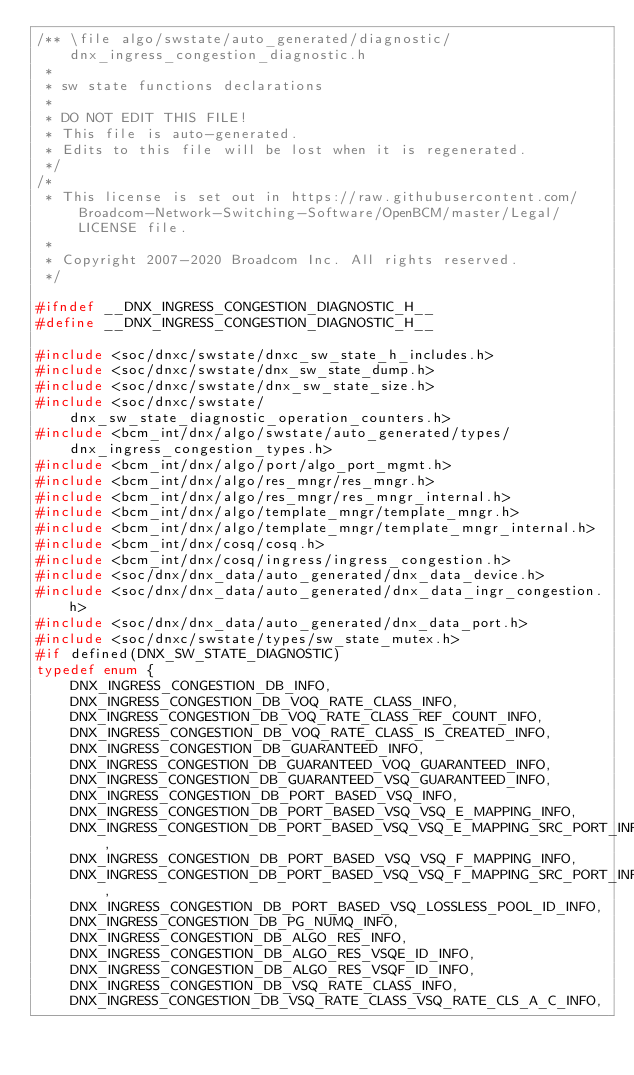Convert code to text. <code><loc_0><loc_0><loc_500><loc_500><_C_>/** \file algo/swstate/auto_generated/diagnostic/dnx_ingress_congestion_diagnostic.h
 *
 * sw state functions declarations
 *
 * DO NOT EDIT THIS FILE!
 * This file is auto-generated.
 * Edits to this file will be lost when it is regenerated.
 */
/*
 * This license is set out in https://raw.githubusercontent.com/Broadcom-Network-Switching-Software/OpenBCM/master/Legal/LICENSE file.
 * 
 * Copyright 2007-2020 Broadcom Inc. All rights reserved.
 */

#ifndef __DNX_INGRESS_CONGESTION_DIAGNOSTIC_H__
#define __DNX_INGRESS_CONGESTION_DIAGNOSTIC_H__

#include <soc/dnxc/swstate/dnxc_sw_state_h_includes.h>
#include <soc/dnxc/swstate/dnx_sw_state_dump.h>
#include <soc/dnxc/swstate/dnx_sw_state_size.h>
#include <soc/dnxc/swstate/dnx_sw_state_diagnostic_operation_counters.h>
#include <bcm_int/dnx/algo/swstate/auto_generated/types/dnx_ingress_congestion_types.h>
#include <bcm_int/dnx/algo/port/algo_port_mgmt.h>
#include <bcm_int/dnx/algo/res_mngr/res_mngr.h>
#include <bcm_int/dnx/algo/res_mngr/res_mngr_internal.h>
#include <bcm_int/dnx/algo/template_mngr/template_mngr.h>
#include <bcm_int/dnx/algo/template_mngr/template_mngr_internal.h>
#include <bcm_int/dnx/cosq/cosq.h>
#include <bcm_int/dnx/cosq/ingress/ingress_congestion.h>
#include <soc/dnx/dnx_data/auto_generated/dnx_data_device.h>
#include <soc/dnx/dnx_data/auto_generated/dnx_data_ingr_congestion.h>
#include <soc/dnx/dnx_data/auto_generated/dnx_data_port.h>
#include <soc/dnxc/swstate/types/sw_state_mutex.h>
#if defined(DNX_SW_STATE_DIAGNOSTIC)
typedef enum {
    DNX_INGRESS_CONGESTION_DB_INFO,
    DNX_INGRESS_CONGESTION_DB_VOQ_RATE_CLASS_INFO,
    DNX_INGRESS_CONGESTION_DB_VOQ_RATE_CLASS_REF_COUNT_INFO,
    DNX_INGRESS_CONGESTION_DB_VOQ_RATE_CLASS_IS_CREATED_INFO,
    DNX_INGRESS_CONGESTION_DB_GUARANTEED_INFO,
    DNX_INGRESS_CONGESTION_DB_GUARANTEED_VOQ_GUARANTEED_INFO,
    DNX_INGRESS_CONGESTION_DB_GUARANTEED_VSQ_GUARANTEED_INFO,
    DNX_INGRESS_CONGESTION_DB_PORT_BASED_VSQ_INFO,
    DNX_INGRESS_CONGESTION_DB_PORT_BASED_VSQ_VSQ_E_MAPPING_INFO,
    DNX_INGRESS_CONGESTION_DB_PORT_BASED_VSQ_VSQ_E_MAPPING_SRC_PORT_INFO,
    DNX_INGRESS_CONGESTION_DB_PORT_BASED_VSQ_VSQ_F_MAPPING_INFO,
    DNX_INGRESS_CONGESTION_DB_PORT_BASED_VSQ_VSQ_F_MAPPING_SRC_PORT_INFO,
    DNX_INGRESS_CONGESTION_DB_PORT_BASED_VSQ_LOSSLESS_POOL_ID_INFO,
    DNX_INGRESS_CONGESTION_DB_PG_NUMQ_INFO,
    DNX_INGRESS_CONGESTION_DB_ALGO_RES_INFO,
    DNX_INGRESS_CONGESTION_DB_ALGO_RES_VSQE_ID_INFO,
    DNX_INGRESS_CONGESTION_DB_ALGO_RES_VSQF_ID_INFO,
    DNX_INGRESS_CONGESTION_DB_VSQ_RATE_CLASS_INFO,
    DNX_INGRESS_CONGESTION_DB_VSQ_RATE_CLASS_VSQ_RATE_CLS_A_C_INFO,</code> 